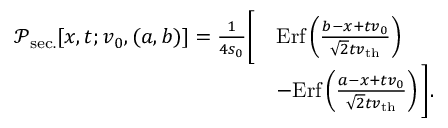Convert formula to latex. <formula><loc_0><loc_0><loc_500><loc_500>\begin{array} { r l } { \mathcal { P } _ { s e c . } [ x , t ; v _ { 0 } , ( a , b ) ] = \frac { 1 } { 4 s _ { 0 } } \left [ } & { E r f \left ( \frac { b - x + t v _ { 0 } } { \sqrt { 2 } t v _ { t h } } \right ) } \\ & { - E r f \left ( \frac { a - x + t v _ { 0 } } { \sqrt { 2 } t v _ { t h } } \right ) \right ] . } \end{array}</formula> 